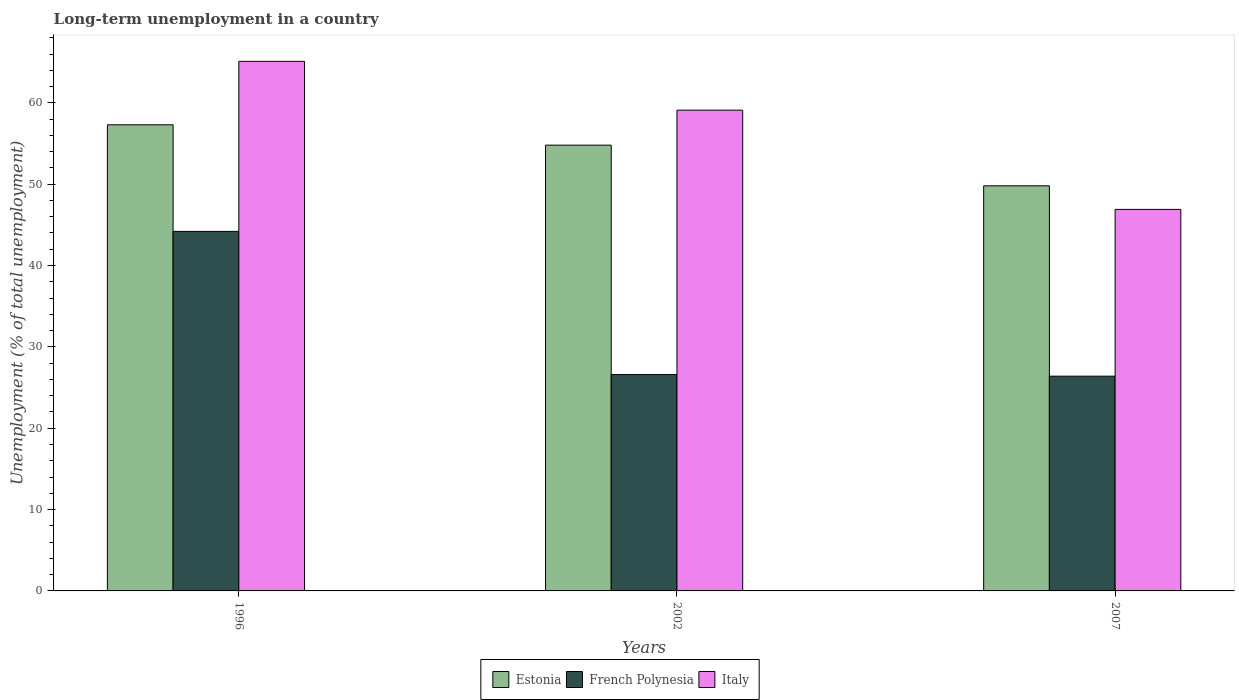How many different coloured bars are there?
Keep it short and to the point. 3. Are the number of bars on each tick of the X-axis equal?
Make the answer very short. Yes. How many bars are there on the 2nd tick from the right?
Ensure brevity in your answer.  3. What is the percentage of long-term unemployed population in Estonia in 2002?
Your answer should be very brief. 54.8. Across all years, what is the maximum percentage of long-term unemployed population in Estonia?
Make the answer very short. 57.3. Across all years, what is the minimum percentage of long-term unemployed population in French Polynesia?
Offer a very short reply. 26.4. In which year was the percentage of long-term unemployed population in French Polynesia minimum?
Ensure brevity in your answer.  2007. What is the total percentage of long-term unemployed population in Italy in the graph?
Provide a succinct answer. 171.1. What is the difference between the percentage of long-term unemployed population in French Polynesia in 2007 and the percentage of long-term unemployed population in Estonia in 1996?
Offer a very short reply. -30.9. What is the average percentage of long-term unemployed population in Italy per year?
Keep it short and to the point. 57.03. In the year 2002, what is the difference between the percentage of long-term unemployed population in French Polynesia and percentage of long-term unemployed population in Estonia?
Your answer should be very brief. -28.2. In how many years, is the percentage of long-term unemployed population in Estonia greater than 36 %?
Offer a very short reply. 3. What is the ratio of the percentage of long-term unemployed population in Italy in 1996 to that in 2007?
Offer a terse response. 1.39. What is the difference between the highest and the second highest percentage of long-term unemployed population in Estonia?
Give a very brief answer. 2.5. What is the difference between the highest and the lowest percentage of long-term unemployed population in Italy?
Provide a succinct answer. 18.2. In how many years, is the percentage of long-term unemployed population in Italy greater than the average percentage of long-term unemployed population in Italy taken over all years?
Your answer should be very brief. 2. Is the sum of the percentage of long-term unemployed population in French Polynesia in 1996 and 2007 greater than the maximum percentage of long-term unemployed population in Estonia across all years?
Your answer should be compact. Yes. What does the 2nd bar from the left in 2002 represents?
Your response must be concise. French Polynesia. Is it the case that in every year, the sum of the percentage of long-term unemployed population in French Polynesia and percentage of long-term unemployed population in Estonia is greater than the percentage of long-term unemployed population in Italy?
Your answer should be compact. Yes. Are all the bars in the graph horizontal?
Keep it short and to the point. No. What is the difference between two consecutive major ticks on the Y-axis?
Make the answer very short. 10. Does the graph contain any zero values?
Offer a terse response. No. Does the graph contain grids?
Keep it short and to the point. No. Where does the legend appear in the graph?
Keep it short and to the point. Bottom center. What is the title of the graph?
Ensure brevity in your answer.  Long-term unemployment in a country. Does "Slovenia" appear as one of the legend labels in the graph?
Make the answer very short. No. What is the label or title of the X-axis?
Your answer should be compact. Years. What is the label or title of the Y-axis?
Keep it short and to the point. Unemployment (% of total unemployment). What is the Unemployment (% of total unemployment) of Estonia in 1996?
Give a very brief answer. 57.3. What is the Unemployment (% of total unemployment) of French Polynesia in 1996?
Provide a short and direct response. 44.2. What is the Unemployment (% of total unemployment) of Italy in 1996?
Ensure brevity in your answer.  65.1. What is the Unemployment (% of total unemployment) in Estonia in 2002?
Keep it short and to the point. 54.8. What is the Unemployment (% of total unemployment) of French Polynesia in 2002?
Keep it short and to the point. 26.6. What is the Unemployment (% of total unemployment) of Italy in 2002?
Provide a short and direct response. 59.1. What is the Unemployment (% of total unemployment) in Estonia in 2007?
Your response must be concise. 49.8. What is the Unemployment (% of total unemployment) in French Polynesia in 2007?
Provide a succinct answer. 26.4. What is the Unemployment (% of total unemployment) in Italy in 2007?
Give a very brief answer. 46.9. Across all years, what is the maximum Unemployment (% of total unemployment) in Estonia?
Keep it short and to the point. 57.3. Across all years, what is the maximum Unemployment (% of total unemployment) in French Polynesia?
Give a very brief answer. 44.2. Across all years, what is the maximum Unemployment (% of total unemployment) in Italy?
Provide a short and direct response. 65.1. Across all years, what is the minimum Unemployment (% of total unemployment) in Estonia?
Your answer should be very brief. 49.8. Across all years, what is the minimum Unemployment (% of total unemployment) in French Polynesia?
Provide a succinct answer. 26.4. Across all years, what is the minimum Unemployment (% of total unemployment) in Italy?
Give a very brief answer. 46.9. What is the total Unemployment (% of total unemployment) of Estonia in the graph?
Make the answer very short. 161.9. What is the total Unemployment (% of total unemployment) of French Polynesia in the graph?
Make the answer very short. 97.2. What is the total Unemployment (% of total unemployment) in Italy in the graph?
Provide a short and direct response. 171.1. What is the difference between the Unemployment (% of total unemployment) in Estonia in 1996 and that in 2007?
Your answer should be very brief. 7.5. What is the difference between the Unemployment (% of total unemployment) of French Polynesia in 1996 and that in 2007?
Provide a short and direct response. 17.8. What is the difference between the Unemployment (% of total unemployment) of Estonia in 2002 and that in 2007?
Your answer should be compact. 5. What is the difference between the Unemployment (% of total unemployment) in French Polynesia in 2002 and that in 2007?
Offer a terse response. 0.2. What is the difference between the Unemployment (% of total unemployment) of Estonia in 1996 and the Unemployment (% of total unemployment) of French Polynesia in 2002?
Offer a terse response. 30.7. What is the difference between the Unemployment (% of total unemployment) in Estonia in 1996 and the Unemployment (% of total unemployment) in Italy in 2002?
Your response must be concise. -1.8. What is the difference between the Unemployment (% of total unemployment) in French Polynesia in 1996 and the Unemployment (% of total unemployment) in Italy in 2002?
Give a very brief answer. -14.9. What is the difference between the Unemployment (% of total unemployment) of Estonia in 1996 and the Unemployment (% of total unemployment) of French Polynesia in 2007?
Make the answer very short. 30.9. What is the difference between the Unemployment (% of total unemployment) in Estonia in 1996 and the Unemployment (% of total unemployment) in Italy in 2007?
Ensure brevity in your answer.  10.4. What is the difference between the Unemployment (% of total unemployment) of French Polynesia in 1996 and the Unemployment (% of total unemployment) of Italy in 2007?
Ensure brevity in your answer.  -2.7. What is the difference between the Unemployment (% of total unemployment) in Estonia in 2002 and the Unemployment (% of total unemployment) in French Polynesia in 2007?
Offer a terse response. 28.4. What is the difference between the Unemployment (% of total unemployment) of French Polynesia in 2002 and the Unemployment (% of total unemployment) of Italy in 2007?
Keep it short and to the point. -20.3. What is the average Unemployment (% of total unemployment) of Estonia per year?
Your answer should be very brief. 53.97. What is the average Unemployment (% of total unemployment) of French Polynesia per year?
Make the answer very short. 32.4. What is the average Unemployment (% of total unemployment) in Italy per year?
Ensure brevity in your answer.  57.03. In the year 1996, what is the difference between the Unemployment (% of total unemployment) of Estonia and Unemployment (% of total unemployment) of French Polynesia?
Your answer should be compact. 13.1. In the year 1996, what is the difference between the Unemployment (% of total unemployment) in French Polynesia and Unemployment (% of total unemployment) in Italy?
Give a very brief answer. -20.9. In the year 2002, what is the difference between the Unemployment (% of total unemployment) in Estonia and Unemployment (% of total unemployment) in French Polynesia?
Provide a short and direct response. 28.2. In the year 2002, what is the difference between the Unemployment (% of total unemployment) in French Polynesia and Unemployment (% of total unemployment) in Italy?
Offer a terse response. -32.5. In the year 2007, what is the difference between the Unemployment (% of total unemployment) in Estonia and Unemployment (% of total unemployment) in French Polynesia?
Keep it short and to the point. 23.4. In the year 2007, what is the difference between the Unemployment (% of total unemployment) in French Polynesia and Unemployment (% of total unemployment) in Italy?
Give a very brief answer. -20.5. What is the ratio of the Unemployment (% of total unemployment) of Estonia in 1996 to that in 2002?
Give a very brief answer. 1.05. What is the ratio of the Unemployment (% of total unemployment) of French Polynesia in 1996 to that in 2002?
Your response must be concise. 1.66. What is the ratio of the Unemployment (% of total unemployment) in Italy in 1996 to that in 2002?
Your answer should be very brief. 1.1. What is the ratio of the Unemployment (% of total unemployment) in Estonia in 1996 to that in 2007?
Ensure brevity in your answer.  1.15. What is the ratio of the Unemployment (% of total unemployment) of French Polynesia in 1996 to that in 2007?
Your answer should be very brief. 1.67. What is the ratio of the Unemployment (% of total unemployment) in Italy in 1996 to that in 2007?
Make the answer very short. 1.39. What is the ratio of the Unemployment (% of total unemployment) of Estonia in 2002 to that in 2007?
Your answer should be very brief. 1.1. What is the ratio of the Unemployment (% of total unemployment) of French Polynesia in 2002 to that in 2007?
Offer a terse response. 1.01. What is the ratio of the Unemployment (% of total unemployment) in Italy in 2002 to that in 2007?
Provide a short and direct response. 1.26. What is the difference between the highest and the second highest Unemployment (% of total unemployment) of French Polynesia?
Your answer should be very brief. 17.6. What is the difference between the highest and the second highest Unemployment (% of total unemployment) of Italy?
Your answer should be very brief. 6. What is the difference between the highest and the lowest Unemployment (% of total unemployment) of Estonia?
Provide a short and direct response. 7.5. What is the difference between the highest and the lowest Unemployment (% of total unemployment) in French Polynesia?
Keep it short and to the point. 17.8. 